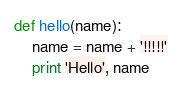<code> <loc_0><loc_0><loc_500><loc_500><_Python_>def hello(name):
    name = name + '!!!!!'
    print 'Hello', name
</code> 